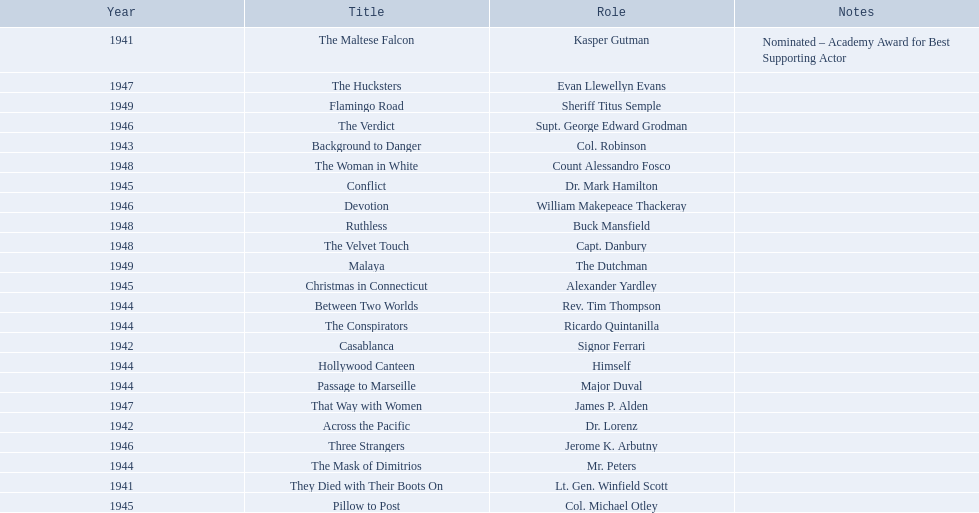What are the movies? The Maltese Falcon, They Died with Their Boots On, Across the Pacific, Casablanca, Background to Danger, Passage to Marseille, Between Two Worlds, The Mask of Dimitrios, The Conspirators, Hollywood Canteen, Pillow to Post, Conflict, Christmas in Connecticut, Three Strangers, Devotion, The Verdict, That Way with Women, The Hucksters, The Velvet Touch, Ruthless, The Woman in White, Flamingo Road, Malaya. Of these, for which did he get nominated for an oscar? The Maltese Falcon. 